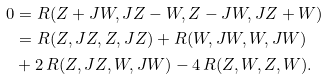Convert formula to latex. <formula><loc_0><loc_0><loc_500><loc_500>0 & = R ( Z + J W , J Z - W , Z - J W , J Z + W ) \\ & = R ( Z , J Z , Z , J Z ) + R ( W , J W , W , J W ) \\ & + 2 \, R ( Z , J Z , W , J W ) - 4 \, R ( Z , W , Z , W ) .</formula> 